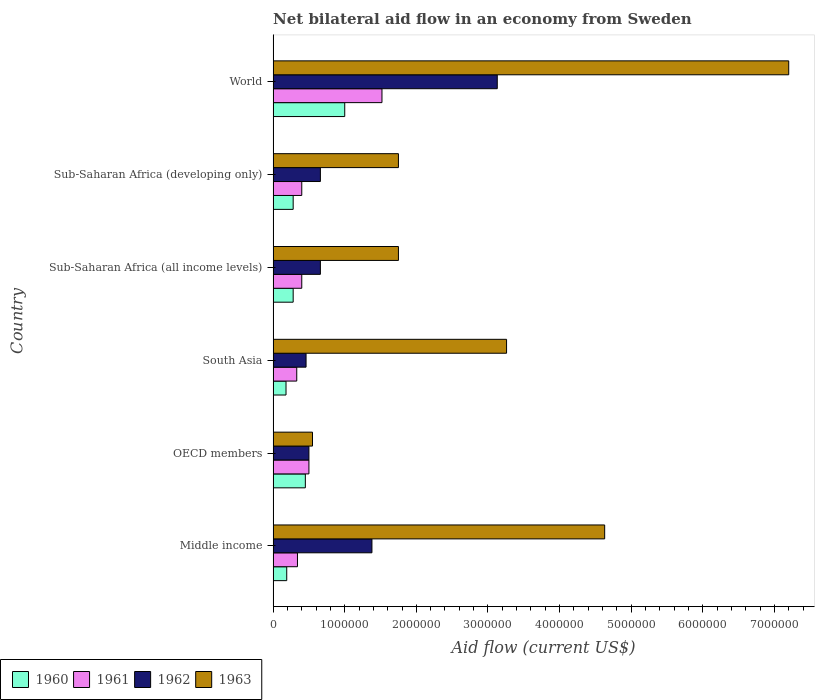How many different coloured bars are there?
Provide a succinct answer. 4. Are the number of bars on each tick of the Y-axis equal?
Offer a very short reply. Yes. How many bars are there on the 3rd tick from the top?
Keep it short and to the point. 4. How many bars are there on the 6th tick from the bottom?
Ensure brevity in your answer.  4. What is the label of the 4th group of bars from the top?
Your answer should be compact. South Asia. What is the net bilateral aid flow in 1961 in World?
Give a very brief answer. 1.52e+06. Across all countries, what is the maximum net bilateral aid flow in 1963?
Your response must be concise. 7.20e+06. In which country was the net bilateral aid flow in 1961 maximum?
Give a very brief answer. World. In which country was the net bilateral aid flow in 1963 minimum?
Your response must be concise. OECD members. What is the total net bilateral aid flow in 1960 in the graph?
Provide a succinct answer. 2.38e+06. What is the difference between the net bilateral aid flow in 1960 in OECD members and the net bilateral aid flow in 1961 in Middle income?
Make the answer very short. 1.10e+05. What is the average net bilateral aid flow in 1960 per country?
Provide a succinct answer. 3.97e+05. What is the difference between the net bilateral aid flow in 1962 and net bilateral aid flow in 1963 in Sub-Saharan Africa (developing only)?
Provide a succinct answer. -1.09e+06. In how many countries, is the net bilateral aid flow in 1960 greater than 1800000 US$?
Your response must be concise. 0. What is the ratio of the net bilateral aid flow in 1963 in Middle income to that in Sub-Saharan Africa (developing only)?
Offer a terse response. 2.65. What is the difference between the highest and the second highest net bilateral aid flow in 1963?
Keep it short and to the point. 2.57e+06. What is the difference between the highest and the lowest net bilateral aid flow in 1961?
Give a very brief answer. 1.19e+06. In how many countries, is the net bilateral aid flow in 1962 greater than the average net bilateral aid flow in 1962 taken over all countries?
Provide a succinct answer. 2. Is the sum of the net bilateral aid flow in 1960 in South Asia and Sub-Saharan Africa (all income levels) greater than the maximum net bilateral aid flow in 1961 across all countries?
Provide a short and direct response. No. Is it the case that in every country, the sum of the net bilateral aid flow in 1962 and net bilateral aid flow in 1961 is greater than the sum of net bilateral aid flow in 1960 and net bilateral aid flow in 1963?
Provide a short and direct response. No. What does the 3rd bar from the top in Middle income represents?
Keep it short and to the point. 1961. Is it the case that in every country, the sum of the net bilateral aid flow in 1962 and net bilateral aid flow in 1961 is greater than the net bilateral aid flow in 1963?
Give a very brief answer. No. How many bars are there?
Give a very brief answer. 24. Are all the bars in the graph horizontal?
Ensure brevity in your answer.  Yes. Are the values on the major ticks of X-axis written in scientific E-notation?
Your answer should be compact. No. Where does the legend appear in the graph?
Keep it short and to the point. Bottom left. How are the legend labels stacked?
Ensure brevity in your answer.  Horizontal. What is the title of the graph?
Ensure brevity in your answer.  Net bilateral aid flow in an economy from Sweden. Does "2006" appear as one of the legend labels in the graph?
Your response must be concise. No. What is the label or title of the X-axis?
Provide a succinct answer. Aid flow (current US$). What is the Aid flow (current US$) of 1960 in Middle income?
Your answer should be compact. 1.90e+05. What is the Aid flow (current US$) in 1962 in Middle income?
Ensure brevity in your answer.  1.38e+06. What is the Aid flow (current US$) of 1963 in Middle income?
Your response must be concise. 4.63e+06. What is the Aid flow (current US$) in 1963 in OECD members?
Offer a very short reply. 5.50e+05. What is the Aid flow (current US$) of 1960 in South Asia?
Give a very brief answer. 1.80e+05. What is the Aid flow (current US$) of 1961 in South Asia?
Provide a succinct answer. 3.30e+05. What is the Aid flow (current US$) in 1963 in South Asia?
Provide a short and direct response. 3.26e+06. What is the Aid flow (current US$) of 1960 in Sub-Saharan Africa (all income levels)?
Give a very brief answer. 2.80e+05. What is the Aid flow (current US$) of 1961 in Sub-Saharan Africa (all income levels)?
Provide a succinct answer. 4.00e+05. What is the Aid flow (current US$) of 1962 in Sub-Saharan Africa (all income levels)?
Your response must be concise. 6.60e+05. What is the Aid flow (current US$) in 1963 in Sub-Saharan Africa (all income levels)?
Keep it short and to the point. 1.75e+06. What is the Aid flow (current US$) in 1961 in Sub-Saharan Africa (developing only)?
Your answer should be very brief. 4.00e+05. What is the Aid flow (current US$) in 1963 in Sub-Saharan Africa (developing only)?
Keep it short and to the point. 1.75e+06. What is the Aid flow (current US$) of 1960 in World?
Give a very brief answer. 1.00e+06. What is the Aid flow (current US$) in 1961 in World?
Give a very brief answer. 1.52e+06. What is the Aid flow (current US$) of 1962 in World?
Give a very brief answer. 3.13e+06. What is the Aid flow (current US$) of 1963 in World?
Keep it short and to the point. 7.20e+06. Across all countries, what is the maximum Aid flow (current US$) of 1960?
Offer a very short reply. 1.00e+06. Across all countries, what is the maximum Aid flow (current US$) of 1961?
Your response must be concise. 1.52e+06. Across all countries, what is the maximum Aid flow (current US$) of 1962?
Ensure brevity in your answer.  3.13e+06. Across all countries, what is the maximum Aid flow (current US$) in 1963?
Keep it short and to the point. 7.20e+06. Across all countries, what is the minimum Aid flow (current US$) in 1961?
Your answer should be compact. 3.30e+05. What is the total Aid flow (current US$) in 1960 in the graph?
Your answer should be compact. 2.38e+06. What is the total Aid flow (current US$) of 1961 in the graph?
Give a very brief answer. 3.49e+06. What is the total Aid flow (current US$) in 1962 in the graph?
Your response must be concise. 6.79e+06. What is the total Aid flow (current US$) in 1963 in the graph?
Provide a short and direct response. 1.91e+07. What is the difference between the Aid flow (current US$) in 1960 in Middle income and that in OECD members?
Offer a very short reply. -2.60e+05. What is the difference between the Aid flow (current US$) in 1961 in Middle income and that in OECD members?
Keep it short and to the point. -1.60e+05. What is the difference between the Aid flow (current US$) in 1962 in Middle income and that in OECD members?
Keep it short and to the point. 8.80e+05. What is the difference between the Aid flow (current US$) of 1963 in Middle income and that in OECD members?
Your answer should be compact. 4.08e+06. What is the difference between the Aid flow (current US$) of 1960 in Middle income and that in South Asia?
Your response must be concise. 10000. What is the difference between the Aid flow (current US$) in 1962 in Middle income and that in South Asia?
Provide a short and direct response. 9.20e+05. What is the difference between the Aid flow (current US$) in 1963 in Middle income and that in South Asia?
Provide a short and direct response. 1.37e+06. What is the difference between the Aid flow (current US$) of 1962 in Middle income and that in Sub-Saharan Africa (all income levels)?
Ensure brevity in your answer.  7.20e+05. What is the difference between the Aid flow (current US$) of 1963 in Middle income and that in Sub-Saharan Africa (all income levels)?
Make the answer very short. 2.88e+06. What is the difference between the Aid flow (current US$) of 1960 in Middle income and that in Sub-Saharan Africa (developing only)?
Ensure brevity in your answer.  -9.00e+04. What is the difference between the Aid flow (current US$) of 1961 in Middle income and that in Sub-Saharan Africa (developing only)?
Ensure brevity in your answer.  -6.00e+04. What is the difference between the Aid flow (current US$) of 1962 in Middle income and that in Sub-Saharan Africa (developing only)?
Provide a succinct answer. 7.20e+05. What is the difference between the Aid flow (current US$) of 1963 in Middle income and that in Sub-Saharan Africa (developing only)?
Offer a terse response. 2.88e+06. What is the difference between the Aid flow (current US$) in 1960 in Middle income and that in World?
Your answer should be very brief. -8.10e+05. What is the difference between the Aid flow (current US$) of 1961 in Middle income and that in World?
Offer a terse response. -1.18e+06. What is the difference between the Aid flow (current US$) of 1962 in Middle income and that in World?
Give a very brief answer. -1.75e+06. What is the difference between the Aid flow (current US$) of 1963 in Middle income and that in World?
Make the answer very short. -2.57e+06. What is the difference between the Aid flow (current US$) of 1961 in OECD members and that in South Asia?
Your answer should be very brief. 1.70e+05. What is the difference between the Aid flow (current US$) of 1962 in OECD members and that in South Asia?
Offer a terse response. 4.00e+04. What is the difference between the Aid flow (current US$) of 1963 in OECD members and that in South Asia?
Provide a succinct answer. -2.71e+06. What is the difference between the Aid flow (current US$) in 1962 in OECD members and that in Sub-Saharan Africa (all income levels)?
Provide a succinct answer. -1.60e+05. What is the difference between the Aid flow (current US$) of 1963 in OECD members and that in Sub-Saharan Africa (all income levels)?
Ensure brevity in your answer.  -1.20e+06. What is the difference between the Aid flow (current US$) in 1960 in OECD members and that in Sub-Saharan Africa (developing only)?
Make the answer very short. 1.70e+05. What is the difference between the Aid flow (current US$) in 1961 in OECD members and that in Sub-Saharan Africa (developing only)?
Provide a succinct answer. 1.00e+05. What is the difference between the Aid flow (current US$) in 1962 in OECD members and that in Sub-Saharan Africa (developing only)?
Offer a very short reply. -1.60e+05. What is the difference between the Aid flow (current US$) in 1963 in OECD members and that in Sub-Saharan Africa (developing only)?
Offer a terse response. -1.20e+06. What is the difference between the Aid flow (current US$) in 1960 in OECD members and that in World?
Give a very brief answer. -5.50e+05. What is the difference between the Aid flow (current US$) of 1961 in OECD members and that in World?
Keep it short and to the point. -1.02e+06. What is the difference between the Aid flow (current US$) in 1962 in OECD members and that in World?
Your answer should be compact. -2.63e+06. What is the difference between the Aid flow (current US$) of 1963 in OECD members and that in World?
Offer a terse response. -6.65e+06. What is the difference between the Aid flow (current US$) in 1960 in South Asia and that in Sub-Saharan Africa (all income levels)?
Make the answer very short. -1.00e+05. What is the difference between the Aid flow (current US$) of 1961 in South Asia and that in Sub-Saharan Africa (all income levels)?
Ensure brevity in your answer.  -7.00e+04. What is the difference between the Aid flow (current US$) in 1963 in South Asia and that in Sub-Saharan Africa (all income levels)?
Your answer should be compact. 1.51e+06. What is the difference between the Aid flow (current US$) of 1961 in South Asia and that in Sub-Saharan Africa (developing only)?
Provide a short and direct response. -7.00e+04. What is the difference between the Aid flow (current US$) of 1962 in South Asia and that in Sub-Saharan Africa (developing only)?
Provide a succinct answer. -2.00e+05. What is the difference between the Aid flow (current US$) of 1963 in South Asia and that in Sub-Saharan Africa (developing only)?
Ensure brevity in your answer.  1.51e+06. What is the difference between the Aid flow (current US$) of 1960 in South Asia and that in World?
Keep it short and to the point. -8.20e+05. What is the difference between the Aid flow (current US$) of 1961 in South Asia and that in World?
Ensure brevity in your answer.  -1.19e+06. What is the difference between the Aid flow (current US$) in 1962 in South Asia and that in World?
Your response must be concise. -2.67e+06. What is the difference between the Aid flow (current US$) of 1963 in South Asia and that in World?
Your answer should be compact. -3.94e+06. What is the difference between the Aid flow (current US$) in 1960 in Sub-Saharan Africa (all income levels) and that in World?
Give a very brief answer. -7.20e+05. What is the difference between the Aid flow (current US$) in 1961 in Sub-Saharan Africa (all income levels) and that in World?
Provide a succinct answer. -1.12e+06. What is the difference between the Aid flow (current US$) of 1962 in Sub-Saharan Africa (all income levels) and that in World?
Make the answer very short. -2.47e+06. What is the difference between the Aid flow (current US$) in 1963 in Sub-Saharan Africa (all income levels) and that in World?
Your response must be concise. -5.45e+06. What is the difference between the Aid flow (current US$) of 1960 in Sub-Saharan Africa (developing only) and that in World?
Make the answer very short. -7.20e+05. What is the difference between the Aid flow (current US$) of 1961 in Sub-Saharan Africa (developing only) and that in World?
Give a very brief answer. -1.12e+06. What is the difference between the Aid flow (current US$) of 1962 in Sub-Saharan Africa (developing only) and that in World?
Keep it short and to the point. -2.47e+06. What is the difference between the Aid flow (current US$) in 1963 in Sub-Saharan Africa (developing only) and that in World?
Offer a very short reply. -5.45e+06. What is the difference between the Aid flow (current US$) in 1960 in Middle income and the Aid flow (current US$) in 1961 in OECD members?
Give a very brief answer. -3.10e+05. What is the difference between the Aid flow (current US$) of 1960 in Middle income and the Aid flow (current US$) of 1962 in OECD members?
Your answer should be compact. -3.10e+05. What is the difference between the Aid flow (current US$) in 1960 in Middle income and the Aid flow (current US$) in 1963 in OECD members?
Give a very brief answer. -3.60e+05. What is the difference between the Aid flow (current US$) of 1961 in Middle income and the Aid flow (current US$) of 1963 in OECD members?
Keep it short and to the point. -2.10e+05. What is the difference between the Aid flow (current US$) of 1962 in Middle income and the Aid flow (current US$) of 1963 in OECD members?
Provide a short and direct response. 8.30e+05. What is the difference between the Aid flow (current US$) of 1960 in Middle income and the Aid flow (current US$) of 1961 in South Asia?
Make the answer very short. -1.40e+05. What is the difference between the Aid flow (current US$) of 1960 in Middle income and the Aid flow (current US$) of 1963 in South Asia?
Provide a succinct answer. -3.07e+06. What is the difference between the Aid flow (current US$) in 1961 in Middle income and the Aid flow (current US$) in 1962 in South Asia?
Provide a succinct answer. -1.20e+05. What is the difference between the Aid flow (current US$) in 1961 in Middle income and the Aid flow (current US$) in 1963 in South Asia?
Make the answer very short. -2.92e+06. What is the difference between the Aid flow (current US$) of 1962 in Middle income and the Aid flow (current US$) of 1963 in South Asia?
Offer a very short reply. -1.88e+06. What is the difference between the Aid flow (current US$) in 1960 in Middle income and the Aid flow (current US$) in 1962 in Sub-Saharan Africa (all income levels)?
Your answer should be compact. -4.70e+05. What is the difference between the Aid flow (current US$) in 1960 in Middle income and the Aid flow (current US$) in 1963 in Sub-Saharan Africa (all income levels)?
Give a very brief answer. -1.56e+06. What is the difference between the Aid flow (current US$) in 1961 in Middle income and the Aid flow (current US$) in 1962 in Sub-Saharan Africa (all income levels)?
Your response must be concise. -3.20e+05. What is the difference between the Aid flow (current US$) of 1961 in Middle income and the Aid flow (current US$) of 1963 in Sub-Saharan Africa (all income levels)?
Offer a terse response. -1.41e+06. What is the difference between the Aid flow (current US$) of 1962 in Middle income and the Aid flow (current US$) of 1963 in Sub-Saharan Africa (all income levels)?
Ensure brevity in your answer.  -3.70e+05. What is the difference between the Aid flow (current US$) in 1960 in Middle income and the Aid flow (current US$) in 1962 in Sub-Saharan Africa (developing only)?
Give a very brief answer. -4.70e+05. What is the difference between the Aid flow (current US$) of 1960 in Middle income and the Aid flow (current US$) of 1963 in Sub-Saharan Africa (developing only)?
Keep it short and to the point. -1.56e+06. What is the difference between the Aid flow (current US$) of 1961 in Middle income and the Aid flow (current US$) of 1962 in Sub-Saharan Africa (developing only)?
Ensure brevity in your answer.  -3.20e+05. What is the difference between the Aid flow (current US$) in 1961 in Middle income and the Aid flow (current US$) in 1963 in Sub-Saharan Africa (developing only)?
Make the answer very short. -1.41e+06. What is the difference between the Aid flow (current US$) of 1962 in Middle income and the Aid flow (current US$) of 1963 in Sub-Saharan Africa (developing only)?
Your answer should be very brief. -3.70e+05. What is the difference between the Aid flow (current US$) of 1960 in Middle income and the Aid flow (current US$) of 1961 in World?
Offer a very short reply. -1.33e+06. What is the difference between the Aid flow (current US$) in 1960 in Middle income and the Aid flow (current US$) in 1962 in World?
Keep it short and to the point. -2.94e+06. What is the difference between the Aid flow (current US$) of 1960 in Middle income and the Aid flow (current US$) of 1963 in World?
Your answer should be compact. -7.01e+06. What is the difference between the Aid flow (current US$) in 1961 in Middle income and the Aid flow (current US$) in 1962 in World?
Ensure brevity in your answer.  -2.79e+06. What is the difference between the Aid flow (current US$) in 1961 in Middle income and the Aid flow (current US$) in 1963 in World?
Your answer should be very brief. -6.86e+06. What is the difference between the Aid flow (current US$) of 1962 in Middle income and the Aid flow (current US$) of 1963 in World?
Provide a short and direct response. -5.82e+06. What is the difference between the Aid flow (current US$) in 1960 in OECD members and the Aid flow (current US$) in 1961 in South Asia?
Your answer should be compact. 1.20e+05. What is the difference between the Aid flow (current US$) of 1960 in OECD members and the Aid flow (current US$) of 1962 in South Asia?
Your answer should be compact. -10000. What is the difference between the Aid flow (current US$) in 1960 in OECD members and the Aid flow (current US$) in 1963 in South Asia?
Ensure brevity in your answer.  -2.81e+06. What is the difference between the Aid flow (current US$) in 1961 in OECD members and the Aid flow (current US$) in 1963 in South Asia?
Offer a very short reply. -2.76e+06. What is the difference between the Aid flow (current US$) of 1962 in OECD members and the Aid flow (current US$) of 1963 in South Asia?
Give a very brief answer. -2.76e+06. What is the difference between the Aid flow (current US$) of 1960 in OECD members and the Aid flow (current US$) of 1963 in Sub-Saharan Africa (all income levels)?
Ensure brevity in your answer.  -1.30e+06. What is the difference between the Aid flow (current US$) of 1961 in OECD members and the Aid flow (current US$) of 1963 in Sub-Saharan Africa (all income levels)?
Make the answer very short. -1.25e+06. What is the difference between the Aid flow (current US$) in 1962 in OECD members and the Aid flow (current US$) in 1963 in Sub-Saharan Africa (all income levels)?
Give a very brief answer. -1.25e+06. What is the difference between the Aid flow (current US$) in 1960 in OECD members and the Aid flow (current US$) in 1961 in Sub-Saharan Africa (developing only)?
Your answer should be compact. 5.00e+04. What is the difference between the Aid flow (current US$) of 1960 in OECD members and the Aid flow (current US$) of 1962 in Sub-Saharan Africa (developing only)?
Provide a succinct answer. -2.10e+05. What is the difference between the Aid flow (current US$) of 1960 in OECD members and the Aid flow (current US$) of 1963 in Sub-Saharan Africa (developing only)?
Offer a very short reply. -1.30e+06. What is the difference between the Aid flow (current US$) in 1961 in OECD members and the Aid flow (current US$) in 1962 in Sub-Saharan Africa (developing only)?
Your answer should be very brief. -1.60e+05. What is the difference between the Aid flow (current US$) in 1961 in OECD members and the Aid flow (current US$) in 1963 in Sub-Saharan Africa (developing only)?
Make the answer very short. -1.25e+06. What is the difference between the Aid flow (current US$) in 1962 in OECD members and the Aid flow (current US$) in 1963 in Sub-Saharan Africa (developing only)?
Offer a very short reply. -1.25e+06. What is the difference between the Aid flow (current US$) of 1960 in OECD members and the Aid flow (current US$) of 1961 in World?
Your answer should be very brief. -1.07e+06. What is the difference between the Aid flow (current US$) of 1960 in OECD members and the Aid flow (current US$) of 1962 in World?
Make the answer very short. -2.68e+06. What is the difference between the Aid flow (current US$) of 1960 in OECD members and the Aid flow (current US$) of 1963 in World?
Your answer should be very brief. -6.75e+06. What is the difference between the Aid flow (current US$) of 1961 in OECD members and the Aid flow (current US$) of 1962 in World?
Your response must be concise. -2.63e+06. What is the difference between the Aid flow (current US$) of 1961 in OECD members and the Aid flow (current US$) of 1963 in World?
Offer a terse response. -6.70e+06. What is the difference between the Aid flow (current US$) in 1962 in OECD members and the Aid flow (current US$) in 1963 in World?
Make the answer very short. -6.70e+06. What is the difference between the Aid flow (current US$) in 1960 in South Asia and the Aid flow (current US$) in 1961 in Sub-Saharan Africa (all income levels)?
Give a very brief answer. -2.20e+05. What is the difference between the Aid flow (current US$) in 1960 in South Asia and the Aid flow (current US$) in 1962 in Sub-Saharan Africa (all income levels)?
Your response must be concise. -4.80e+05. What is the difference between the Aid flow (current US$) in 1960 in South Asia and the Aid flow (current US$) in 1963 in Sub-Saharan Africa (all income levels)?
Your response must be concise. -1.57e+06. What is the difference between the Aid flow (current US$) of 1961 in South Asia and the Aid flow (current US$) of 1962 in Sub-Saharan Africa (all income levels)?
Make the answer very short. -3.30e+05. What is the difference between the Aid flow (current US$) in 1961 in South Asia and the Aid flow (current US$) in 1963 in Sub-Saharan Africa (all income levels)?
Your answer should be compact. -1.42e+06. What is the difference between the Aid flow (current US$) in 1962 in South Asia and the Aid flow (current US$) in 1963 in Sub-Saharan Africa (all income levels)?
Ensure brevity in your answer.  -1.29e+06. What is the difference between the Aid flow (current US$) of 1960 in South Asia and the Aid flow (current US$) of 1961 in Sub-Saharan Africa (developing only)?
Provide a short and direct response. -2.20e+05. What is the difference between the Aid flow (current US$) in 1960 in South Asia and the Aid flow (current US$) in 1962 in Sub-Saharan Africa (developing only)?
Offer a very short reply. -4.80e+05. What is the difference between the Aid flow (current US$) of 1960 in South Asia and the Aid flow (current US$) of 1963 in Sub-Saharan Africa (developing only)?
Ensure brevity in your answer.  -1.57e+06. What is the difference between the Aid flow (current US$) in 1961 in South Asia and the Aid flow (current US$) in 1962 in Sub-Saharan Africa (developing only)?
Offer a very short reply. -3.30e+05. What is the difference between the Aid flow (current US$) of 1961 in South Asia and the Aid flow (current US$) of 1963 in Sub-Saharan Africa (developing only)?
Provide a short and direct response. -1.42e+06. What is the difference between the Aid flow (current US$) of 1962 in South Asia and the Aid flow (current US$) of 1963 in Sub-Saharan Africa (developing only)?
Provide a succinct answer. -1.29e+06. What is the difference between the Aid flow (current US$) of 1960 in South Asia and the Aid flow (current US$) of 1961 in World?
Give a very brief answer. -1.34e+06. What is the difference between the Aid flow (current US$) of 1960 in South Asia and the Aid flow (current US$) of 1962 in World?
Make the answer very short. -2.95e+06. What is the difference between the Aid flow (current US$) of 1960 in South Asia and the Aid flow (current US$) of 1963 in World?
Keep it short and to the point. -7.02e+06. What is the difference between the Aid flow (current US$) in 1961 in South Asia and the Aid flow (current US$) in 1962 in World?
Ensure brevity in your answer.  -2.80e+06. What is the difference between the Aid flow (current US$) of 1961 in South Asia and the Aid flow (current US$) of 1963 in World?
Provide a succinct answer. -6.87e+06. What is the difference between the Aid flow (current US$) of 1962 in South Asia and the Aid flow (current US$) of 1963 in World?
Ensure brevity in your answer.  -6.74e+06. What is the difference between the Aid flow (current US$) in 1960 in Sub-Saharan Africa (all income levels) and the Aid flow (current US$) in 1962 in Sub-Saharan Africa (developing only)?
Your response must be concise. -3.80e+05. What is the difference between the Aid flow (current US$) of 1960 in Sub-Saharan Africa (all income levels) and the Aid flow (current US$) of 1963 in Sub-Saharan Africa (developing only)?
Keep it short and to the point. -1.47e+06. What is the difference between the Aid flow (current US$) of 1961 in Sub-Saharan Africa (all income levels) and the Aid flow (current US$) of 1962 in Sub-Saharan Africa (developing only)?
Provide a succinct answer. -2.60e+05. What is the difference between the Aid flow (current US$) of 1961 in Sub-Saharan Africa (all income levels) and the Aid flow (current US$) of 1963 in Sub-Saharan Africa (developing only)?
Offer a very short reply. -1.35e+06. What is the difference between the Aid flow (current US$) of 1962 in Sub-Saharan Africa (all income levels) and the Aid flow (current US$) of 1963 in Sub-Saharan Africa (developing only)?
Provide a succinct answer. -1.09e+06. What is the difference between the Aid flow (current US$) of 1960 in Sub-Saharan Africa (all income levels) and the Aid flow (current US$) of 1961 in World?
Make the answer very short. -1.24e+06. What is the difference between the Aid flow (current US$) in 1960 in Sub-Saharan Africa (all income levels) and the Aid flow (current US$) in 1962 in World?
Offer a terse response. -2.85e+06. What is the difference between the Aid flow (current US$) of 1960 in Sub-Saharan Africa (all income levels) and the Aid flow (current US$) of 1963 in World?
Make the answer very short. -6.92e+06. What is the difference between the Aid flow (current US$) of 1961 in Sub-Saharan Africa (all income levels) and the Aid flow (current US$) of 1962 in World?
Offer a terse response. -2.73e+06. What is the difference between the Aid flow (current US$) of 1961 in Sub-Saharan Africa (all income levels) and the Aid flow (current US$) of 1963 in World?
Your answer should be compact. -6.80e+06. What is the difference between the Aid flow (current US$) of 1962 in Sub-Saharan Africa (all income levels) and the Aid flow (current US$) of 1963 in World?
Your answer should be compact. -6.54e+06. What is the difference between the Aid flow (current US$) of 1960 in Sub-Saharan Africa (developing only) and the Aid flow (current US$) of 1961 in World?
Offer a terse response. -1.24e+06. What is the difference between the Aid flow (current US$) in 1960 in Sub-Saharan Africa (developing only) and the Aid flow (current US$) in 1962 in World?
Your answer should be compact. -2.85e+06. What is the difference between the Aid flow (current US$) of 1960 in Sub-Saharan Africa (developing only) and the Aid flow (current US$) of 1963 in World?
Keep it short and to the point. -6.92e+06. What is the difference between the Aid flow (current US$) of 1961 in Sub-Saharan Africa (developing only) and the Aid flow (current US$) of 1962 in World?
Your response must be concise. -2.73e+06. What is the difference between the Aid flow (current US$) in 1961 in Sub-Saharan Africa (developing only) and the Aid flow (current US$) in 1963 in World?
Your answer should be compact. -6.80e+06. What is the difference between the Aid flow (current US$) in 1962 in Sub-Saharan Africa (developing only) and the Aid flow (current US$) in 1963 in World?
Keep it short and to the point. -6.54e+06. What is the average Aid flow (current US$) of 1960 per country?
Keep it short and to the point. 3.97e+05. What is the average Aid flow (current US$) in 1961 per country?
Offer a terse response. 5.82e+05. What is the average Aid flow (current US$) in 1962 per country?
Keep it short and to the point. 1.13e+06. What is the average Aid flow (current US$) in 1963 per country?
Give a very brief answer. 3.19e+06. What is the difference between the Aid flow (current US$) in 1960 and Aid flow (current US$) in 1961 in Middle income?
Your answer should be very brief. -1.50e+05. What is the difference between the Aid flow (current US$) of 1960 and Aid flow (current US$) of 1962 in Middle income?
Give a very brief answer. -1.19e+06. What is the difference between the Aid flow (current US$) of 1960 and Aid flow (current US$) of 1963 in Middle income?
Offer a very short reply. -4.44e+06. What is the difference between the Aid flow (current US$) of 1961 and Aid flow (current US$) of 1962 in Middle income?
Offer a very short reply. -1.04e+06. What is the difference between the Aid flow (current US$) in 1961 and Aid flow (current US$) in 1963 in Middle income?
Provide a succinct answer. -4.29e+06. What is the difference between the Aid flow (current US$) of 1962 and Aid flow (current US$) of 1963 in Middle income?
Your answer should be compact. -3.25e+06. What is the difference between the Aid flow (current US$) of 1960 and Aid flow (current US$) of 1961 in OECD members?
Your answer should be very brief. -5.00e+04. What is the difference between the Aid flow (current US$) of 1960 and Aid flow (current US$) of 1963 in OECD members?
Offer a terse response. -1.00e+05. What is the difference between the Aid flow (current US$) of 1962 and Aid flow (current US$) of 1963 in OECD members?
Provide a succinct answer. -5.00e+04. What is the difference between the Aid flow (current US$) in 1960 and Aid flow (current US$) in 1962 in South Asia?
Your response must be concise. -2.80e+05. What is the difference between the Aid flow (current US$) of 1960 and Aid flow (current US$) of 1963 in South Asia?
Ensure brevity in your answer.  -3.08e+06. What is the difference between the Aid flow (current US$) of 1961 and Aid flow (current US$) of 1962 in South Asia?
Provide a short and direct response. -1.30e+05. What is the difference between the Aid flow (current US$) in 1961 and Aid flow (current US$) in 1963 in South Asia?
Your response must be concise. -2.93e+06. What is the difference between the Aid flow (current US$) of 1962 and Aid flow (current US$) of 1963 in South Asia?
Provide a succinct answer. -2.80e+06. What is the difference between the Aid flow (current US$) in 1960 and Aid flow (current US$) in 1961 in Sub-Saharan Africa (all income levels)?
Give a very brief answer. -1.20e+05. What is the difference between the Aid flow (current US$) of 1960 and Aid flow (current US$) of 1962 in Sub-Saharan Africa (all income levels)?
Provide a succinct answer. -3.80e+05. What is the difference between the Aid flow (current US$) in 1960 and Aid flow (current US$) in 1963 in Sub-Saharan Africa (all income levels)?
Provide a succinct answer. -1.47e+06. What is the difference between the Aid flow (current US$) in 1961 and Aid flow (current US$) in 1963 in Sub-Saharan Africa (all income levels)?
Your answer should be very brief. -1.35e+06. What is the difference between the Aid flow (current US$) in 1962 and Aid flow (current US$) in 1963 in Sub-Saharan Africa (all income levels)?
Ensure brevity in your answer.  -1.09e+06. What is the difference between the Aid flow (current US$) of 1960 and Aid flow (current US$) of 1961 in Sub-Saharan Africa (developing only)?
Offer a very short reply. -1.20e+05. What is the difference between the Aid flow (current US$) in 1960 and Aid flow (current US$) in 1962 in Sub-Saharan Africa (developing only)?
Provide a succinct answer. -3.80e+05. What is the difference between the Aid flow (current US$) in 1960 and Aid flow (current US$) in 1963 in Sub-Saharan Africa (developing only)?
Provide a succinct answer. -1.47e+06. What is the difference between the Aid flow (current US$) in 1961 and Aid flow (current US$) in 1962 in Sub-Saharan Africa (developing only)?
Provide a short and direct response. -2.60e+05. What is the difference between the Aid flow (current US$) in 1961 and Aid flow (current US$) in 1963 in Sub-Saharan Africa (developing only)?
Ensure brevity in your answer.  -1.35e+06. What is the difference between the Aid flow (current US$) of 1962 and Aid flow (current US$) of 1963 in Sub-Saharan Africa (developing only)?
Keep it short and to the point. -1.09e+06. What is the difference between the Aid flow (current US$) in 1960 and Aid flow (current US$) in 1961 in World?
Ensure brevity in your answer.  -5.20e+05. What is the difference between the Aid flow (current US$) of 1960 and Aid flow (current US$) of 1962 in World?
Keep it short and to the point. -2.13e+06. What is the difference between the Aid flow (current US$) in 1960 and Aid flow (current US$) in 1963 in World?
Your answer should be compact. -6.20e+06. What is the difference between the Aid flow (current US$) in 1961 and Aid flow (current US$) in 1962 in World?
Offer a terse response. -1.61e+06. What is the difference between the Aid flow (current US$) of 1961 and Aid flow (current US$) of 1963 in World?
Your answer should be very brief. -5.68e+06. What is the difference between the Aid flow (current US$) of 1962 and Aid flow (current US$) of 1963 in World?
Provide a succinct answer. -4.07e+06. What is the ratio of the Aid flow (current US$) of 1960 in Middle income to that in OECD members?
Make the answer very short. 0.42. What is the ratio of the Aid flow (current US$) of 1961 in Middle income to that in OECD members?
Provide a succinct answer. 0.68. What is the ratio of the Aid flow (current US$) in 1962 in Middle income to that in OECD members?
Ensure brevity in your answer.  2.76. What is the ratio of the Aid flow (current US$) in 1963 in Middle income to that in OECD members?
Your answer should be very brief. 8.42. What is the ratio of the Aid flow (current US$) of 1960 in Middle income to that in South Asia?
Make the answer very short. 1.06. What is the ratio of the Aid flow (current US$) in 1961 in Middle income to that in South Asia?
Ensure brevity in your answer.  1.03. What is the ratio of the Aid flow (current US$) in 1963 in Middle income to that in South Asia?
Your response must be concise. 1.42. What is the ratio of the Aid flow (current US$) in 1960 in Middle income to that in Sub-Saharan Africa (all income levels)?
Keep it short and to the point. 0.68. What is the ratio of the Aid flow (current US$) in 1962 in Middle income to that in Sub-Saharan Africa (all income levels)?
Provide a succinct answer. 2.09. What is the ratio of the Aid flow (current US$) of 1963 in Middle income to that in Sub-Saharan Africa (all income levels)?
Your answer should be compact. 2.65. What is the ratio of the Aid flow (current US$) in 1960 in Middle income to that in Sub-Saharan Africa (developing only)?
Offer a terse response. 0.68. What is the ratio of the Aid flow (current US$) in 1962 in Middle income to that in Sub-Saharan Africa (developing only)?
Give a very brief answer. 2.09. What is the ratio of the Aid flow (current US$) of 1963 in Middle income to that in Sub-Saharan Africa (developing only)?
Offer a very short reply. 2.65. What is the ratio of the Aid flow (current US$) of 1960 in Middle income to that in World?
Make the answer very short. 0.19. What is the ratio of the Aid flow (current US$) in 1961 in Middle income to that in World?
Keep it short and to the point. 0.22. What is the ratio of the Aid flow (current US$) in 1962 in Middle income to that in World?
Your response must be concise. 0.44. What is the ratio of the Aid flow (current US$) in 1963 in Middle income to that in World?
Ensure brevity in your answer.  0.64. What is the ratio of the Aid flow (current US$) in 1960 in OECD members to that in South Asia?
Your response must be concise. 2.5. What is the ratio of the Aid flow (current US$) of 1961 in OECD members to that in South Asia?
Provide a short and direct response. 1.52. What is the ratio of the Aid flow (current US$) of 1962 in OECD members to that in South Asia?
Your answer should be very brief. 1.09. What is the ratio of the Aid flow (current US$) in 1963 in OECD members to that in South Asia?
Your answer should be compact. 0.17. What is the ratio of the Aid flow (current US$) of 1960 in OECD members to that in Sub-Saharan Africa (all income levels)?
Make the answer very short. 1.61. What is the ratio of the Aid flow (current US$) of 1961 in OECD members to that in Sub-Saharan Africa (all income levels)?
Provide a succinct answer. 1.25. What is the ratio of the Aid flow (current US$) of 1962 in OECD members to that in Sub-Saharan Africa (all income levels)?
Provide a succinct answer. 0.76. What is the ratio of the Aid flow (current US$) in 1963 in OECD members to that in Sub-Saharan Africa (all income levels)?
Offer a terse response. 0.31. What is the ratio of the Aid flow (current US$) of 1960 in OECD members to that in Sub-Saharan Africa (developing only)?
Offer a very short reply. 1.61. What is the ratio of the Aid flow (current US$) of 1962 in OECD members to that in Sub-Saharan Africa (developing only)?
Your answer should be very brief. 0.76. What is the ratio of the Aid flow (current US$) of 1963 in OECD members to that in Sub-Saharan Africa (developing only)?
Make the answer very short. 0.31. What is the ratio of the Aid flow (current US$) of 1960 in OECD members to that in World?
Give a very brief answer. 0.45. What is the ratio of the Aid flow (current US$) of 1961 in OECD members to that in World?
Your response must be concise. 0.33. What is the ratio of the Aid flow (current US$) of 1962 in OECD members to that in World?
Your answer should be very brief. 0.16. What is the ratio of the Aid flow (current US$) in 1963 in OECD members to that in World?
Provide a short and direct response. 0.08. What is the ratio of the Aid flow (current US$) of 1960 in South Asia to that in Sub-Saharan Africa (all income levels)?
Keep it short and to the point. 0.64. What is the ratio of the Aid flow (current US$) of 1961 in South Asia to that in Sub-Saharan Africa (all income levels)?
Ensure brevity in your answer.  0.82. What is the ratio of the Aid flow (current US$) in 1962 in South Asia to that in Sub-Saharan Africa (all income levels)?
Provide a succinct answer. 0.7. What is the ratio of the Aid flow (current US$) of 1963 in South Asia to that in Sub-Saharan Africa (all income levels)?
Make the answer very short. 1.86. What is the ratio of the Aid flow (current US$) of 1960 in South Asia to that in Sub-Saharan Africa (developing only)?
Keep it short and to the point. 0.64. What is the ratio of the Aid flow (current US$) of 1961 in South Asia to that in Sub-Saharan Africa (developing only)?
Offer a very short reply. 0.82. What is the ratio of the Aid flow (current US$) of 1962 in South Asia to that in Sub-Saharan Africa (developing only)?
Your answer should be very brief. 0.7. What is the ratio of the Aid flow (current US$) in 1963 in South Asia to that in Sub-Saharan Africa (developing only)?
Your answer should be very brief. 1.86. What is the ratio of the Aid flow (current US$) of 1960 in South Asia to that in World?
Your answer should be very brief. 0.18. What is the ratio of the Aid flow (current US$) of 1961 in South Asia to that in World?
Your answer should be compact. 0.22. What is the ratio of the Aid flow (current US$) of 1962 in South Asia to that in World?
Ensure brevity in your answer.  0.15. What is the ratio of the Aid flow (current US$) of 1963 in South Asia to that in World?
Your answer should be very brief. 0.45. What is the ratio of the Aid flow (current US$) of 1961 in Sub-Saharan Africa (all income levels) to that in Sub-Saharan Africa (developing only)?
Offer a very short reply. 1. What is the ratio of the Aid flow (current US$) in 1963 in Sub-Saharan Africa (all income levels) to that in Sub-Saharan Africa (developing only)?
Ensure brevity in your answer.  1. What is the ratio of the Aid flow (current US$) in 1960 in Sub-Saharan Africa (all income levels) to that in World?
Provide a succinct answer. 0.28. What is the ratio of the Aid flow (current US$) of 1961 in Sub-Saharan Africa (all income levels) to that in World?
Your answer should be compact. 0.26. What is the ratio of the Aid flow (current US$) in 1962 in Sub-Saharan Africa (all income levels) to that in World?
Make the answer very short. 0.21. What is the ratio of the Aid flow (current US$) in 1963 in Sub-Saharan Africa (all income levels) to that in World?
Your answer should be compact. 0.24. What is the ratio of the Aid flow (current US$) of 1960 in Sub-Saharan Africa (developing only) to that in World?
Your response must be concise. 0.28. What is the ratio of the Aid flow (current US$) of 1961 in Sub-Saharan Africa (developing only) to that in World?
Make the answer very short. 0.26. What is the ratio of the Aid flow (current US$) in 1962 in Sub-Saharan Africa (developing only) to that in World?
Provide a succinct answer. 0.21. What is the ratio of the Aid flow (current US$) of 1963 in Sub-Saharan Africa (developing only) to that in World?
Provide a succinct answer. 0.24. What is the difference between the highest and the second highest Aid flow (current US$) of 1961?
Ensure brevity in your answer.  1.02e+06. What is the difference between the highest and the second highest Aid flow (current US$) in 1962?
Your response must be concise. 1.75e+06. What is the difference between the highest and the second highest Aid flow (current US$) of 1963?
Make the answer very short. 2.57e+06. What is the difference between the highest and the lowest Aid flow (current US$) in 1960?
Provide a succinct answer. 8.20e+05. What is the difference between the highest and the lowest Aid flow (current US$) of 1961?
Offer a very short reply. 1.19e+06. What is the difference between the highest and the lowest Aid flow (current US$) of 1962?
Provide a short and direct response. 2.67e+06. What is the difference between the highest and the lowest Aid flow (current US$) of 1963?
Offer a very short reply. 6.65e+06. 